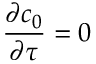Convert formula to latex. <formula><loc_0><loc_0><loc_500><loc_500>\frac { \partial c _ { 0 } } { \partial \tau } = 0</formula> 